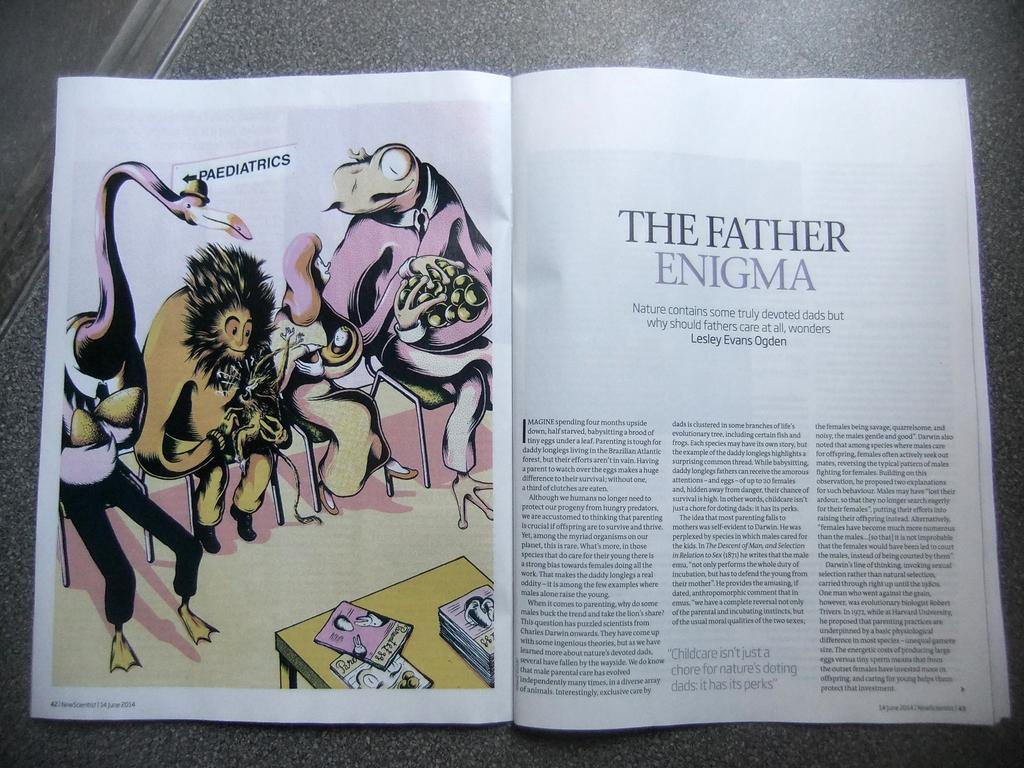What does the sign say that is pointing left in the image?
Your answer should be compact. Paediatrics. 